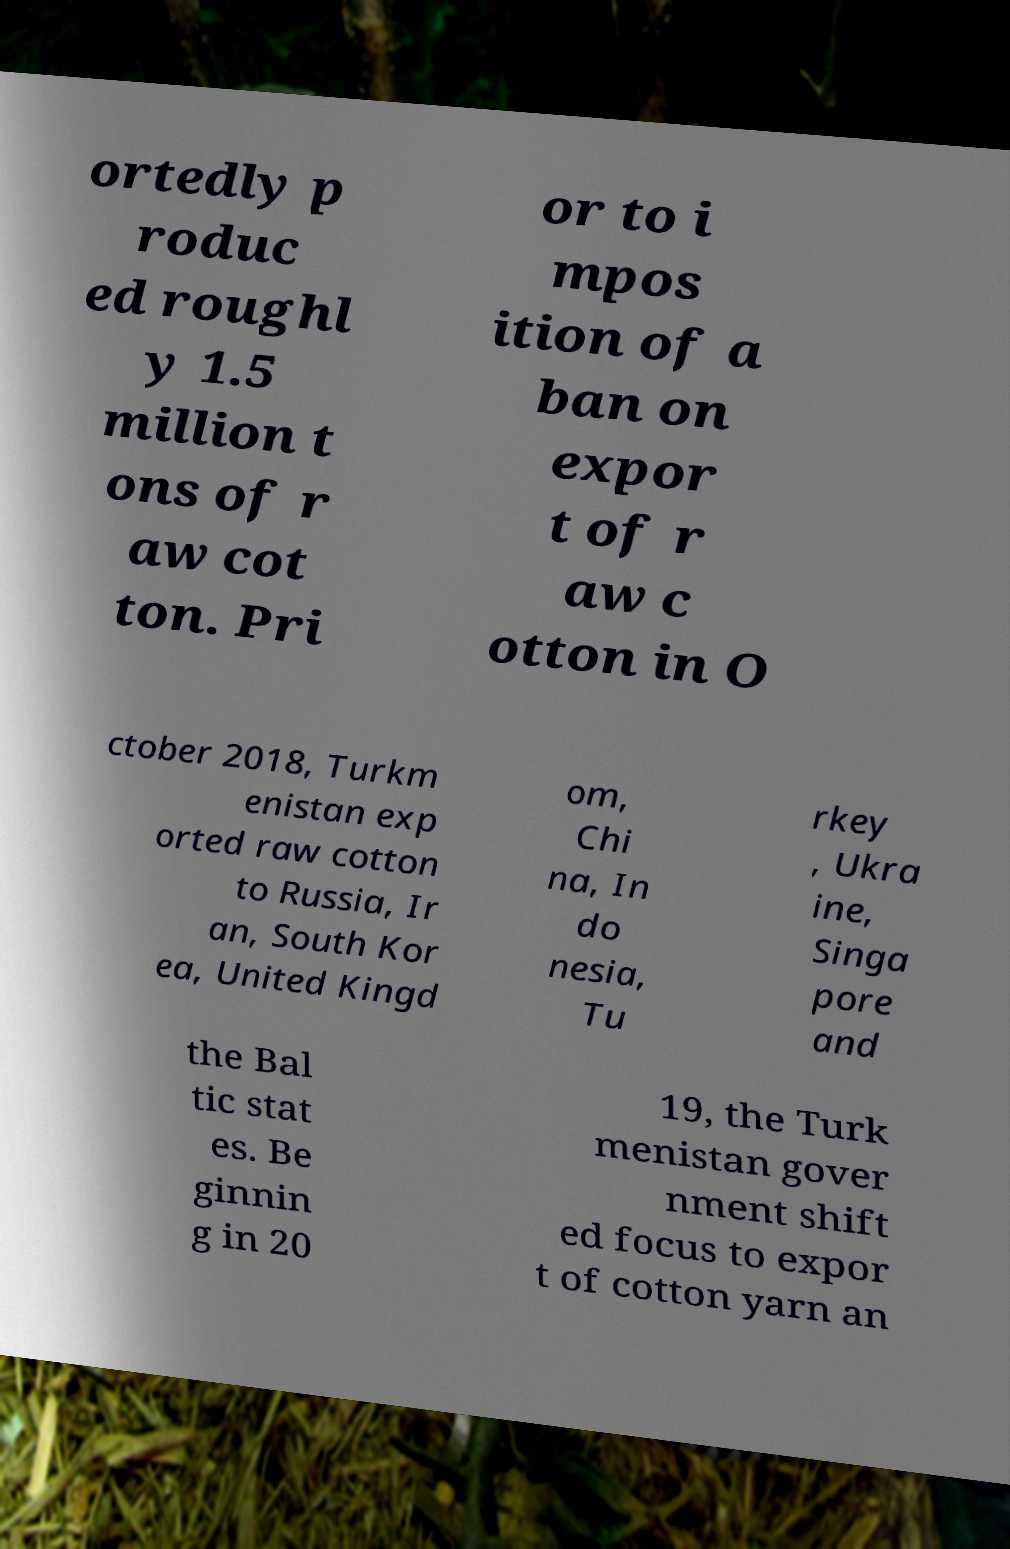There's text embedded in this image that I need extracted. Can you transcribe it verbatim? ortedly p roduc ed roughl y 1.5 million t ons of r aw cot ton. Pri or to i mpos ition of a ban on expor t of r aw c otton in O ctober 2018, Turkm enistan exp orted raw cotton to Russia, Ir an, South Kor ea, United Kingd om, Chi na, In do nesia, Tu rkey , Ukra ine, Singa pore and the Bal tic stat es. Be ginnin g in 20 19, the Turk menistan gover nment shift ed focus to expor t of cotton yarn an 